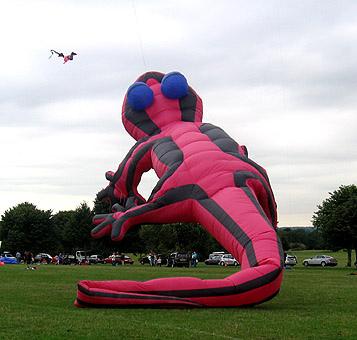How many balloons are in the air?
Quick response, please. 1. What color are the eyelids?
Short answer required. Blue. What is this balloon/kite?
Short answer required. Lizard. 